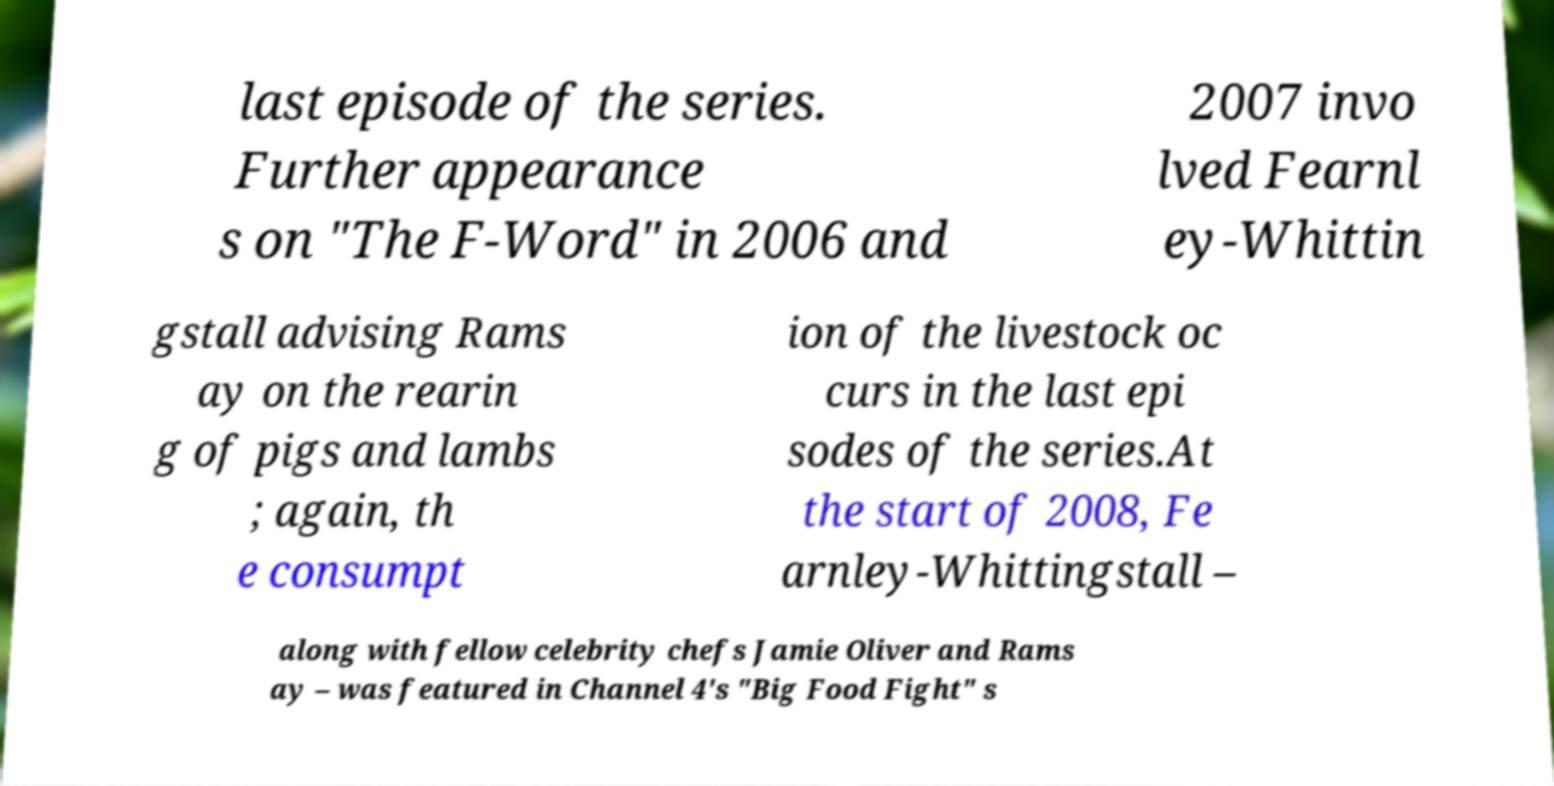There's text embedded in this image that I need extracted. Can you transcribe it verbatim? last episode of the series. Further appearance s on "The F-Word" in 2006 and 2007 invo lved Fearnl ey-Whittin gstall advising Rams ay on the rearin g of pigs and lambs ; again, th e consumpt ion of the livestock oc curs in the last epi sodes of the series.At the start of 2008, Fe arnley-Whittingstall – along with fellow celebrity chefs Jamie Oliver and Rams ay – was featured in Channel 4's "Big Food Fight" s 